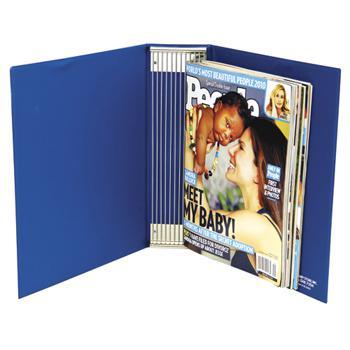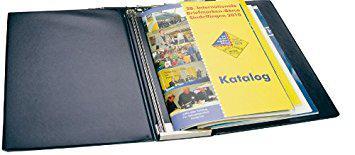The first image is the image on the left, the second image is the image on the right. For the images displayed, is the sentence "The left image includes a binder with a magazine featuring a woman on the cover." factually correct? Answer yes or no. Yes. The first image is the image on the left, the second image is the image on the right. Considering the images on both sides, is "There are two binders against a white background." valid? Answer yes or no. Yes. 